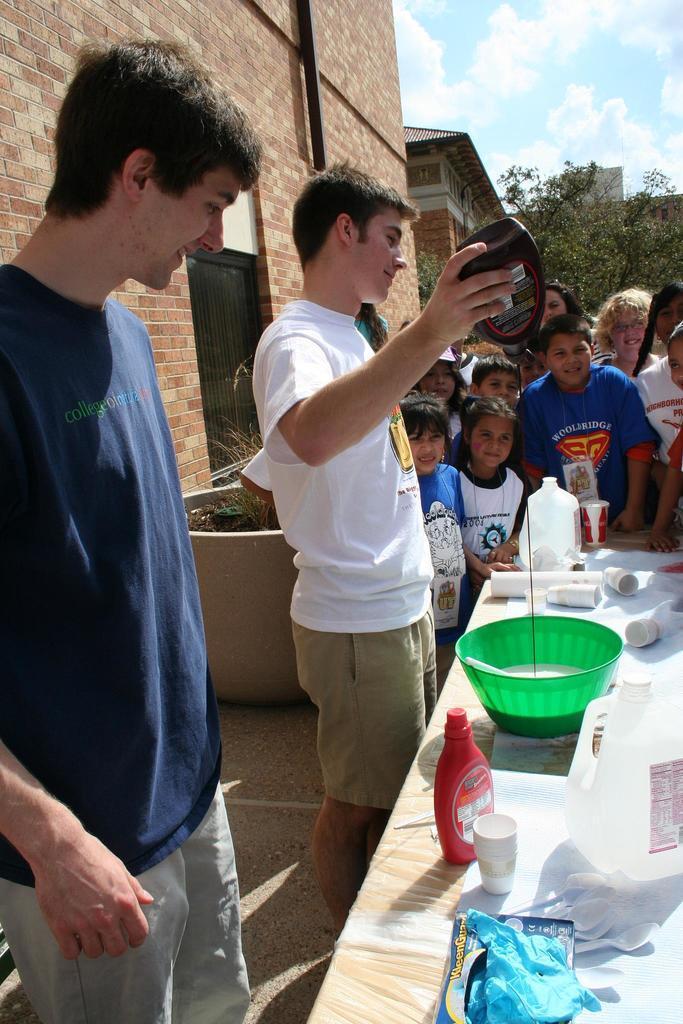Could you give a brief overview of what you see in this image? In the image there are two men and there is a table in front of them, on the table there is a bowl and the man is pouring some syrup into the bowl, around that there are some other items, behind the table there are a group of kids and on the left side there is a wall, beside the wall there are some trees. 